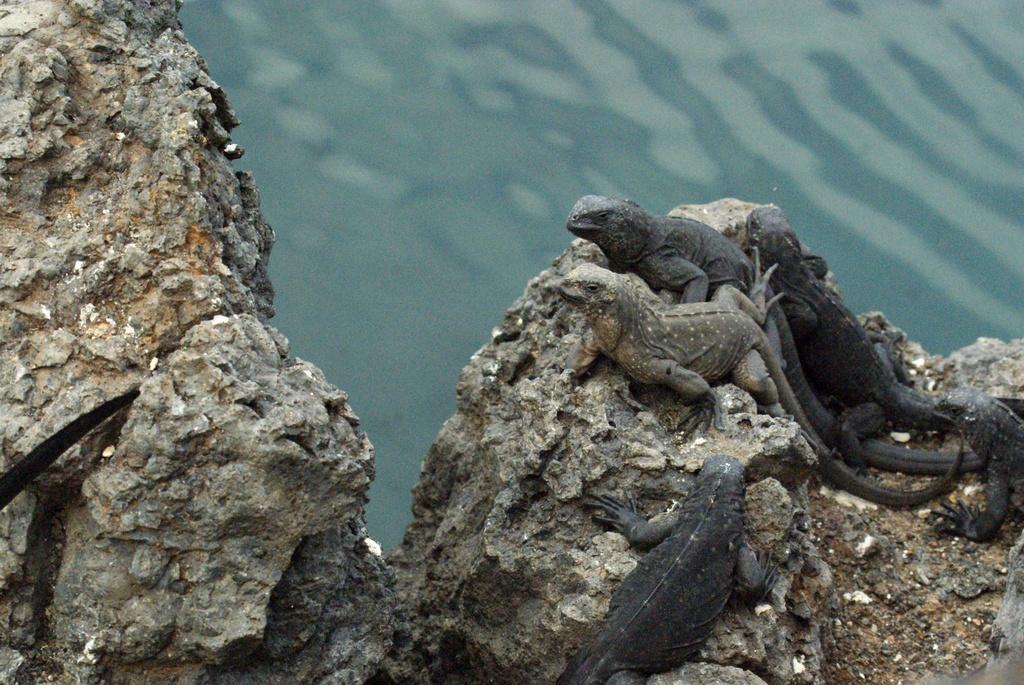In one or two sentences, can you explain what this image depicts? In this image I can see few reptiles which are brown and black in color on the rock. In the background I can see the water. 